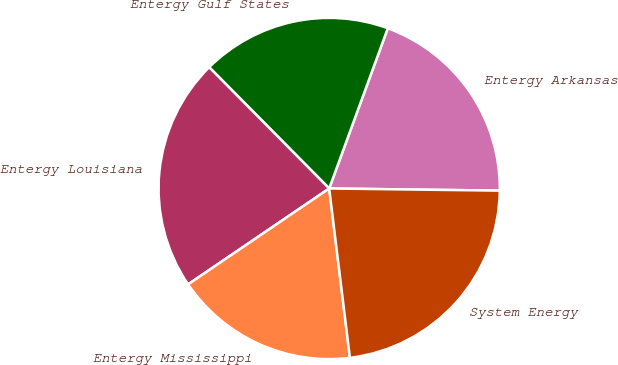Convert chart. <chart><loc_0><loc_0><loc_500><loc_500><pie_chart><fcel>Entergy Arkansas<fcel>Entergy Gulf States<fcel>Entergy Louisiana<fcel>Entergy Mississippi<fcel>System Energy<nl><fcel>19.62%<fcel>18.0%<fcel>22.08%<fcel>17.44%<fcel>22.86%<nl></chart> 